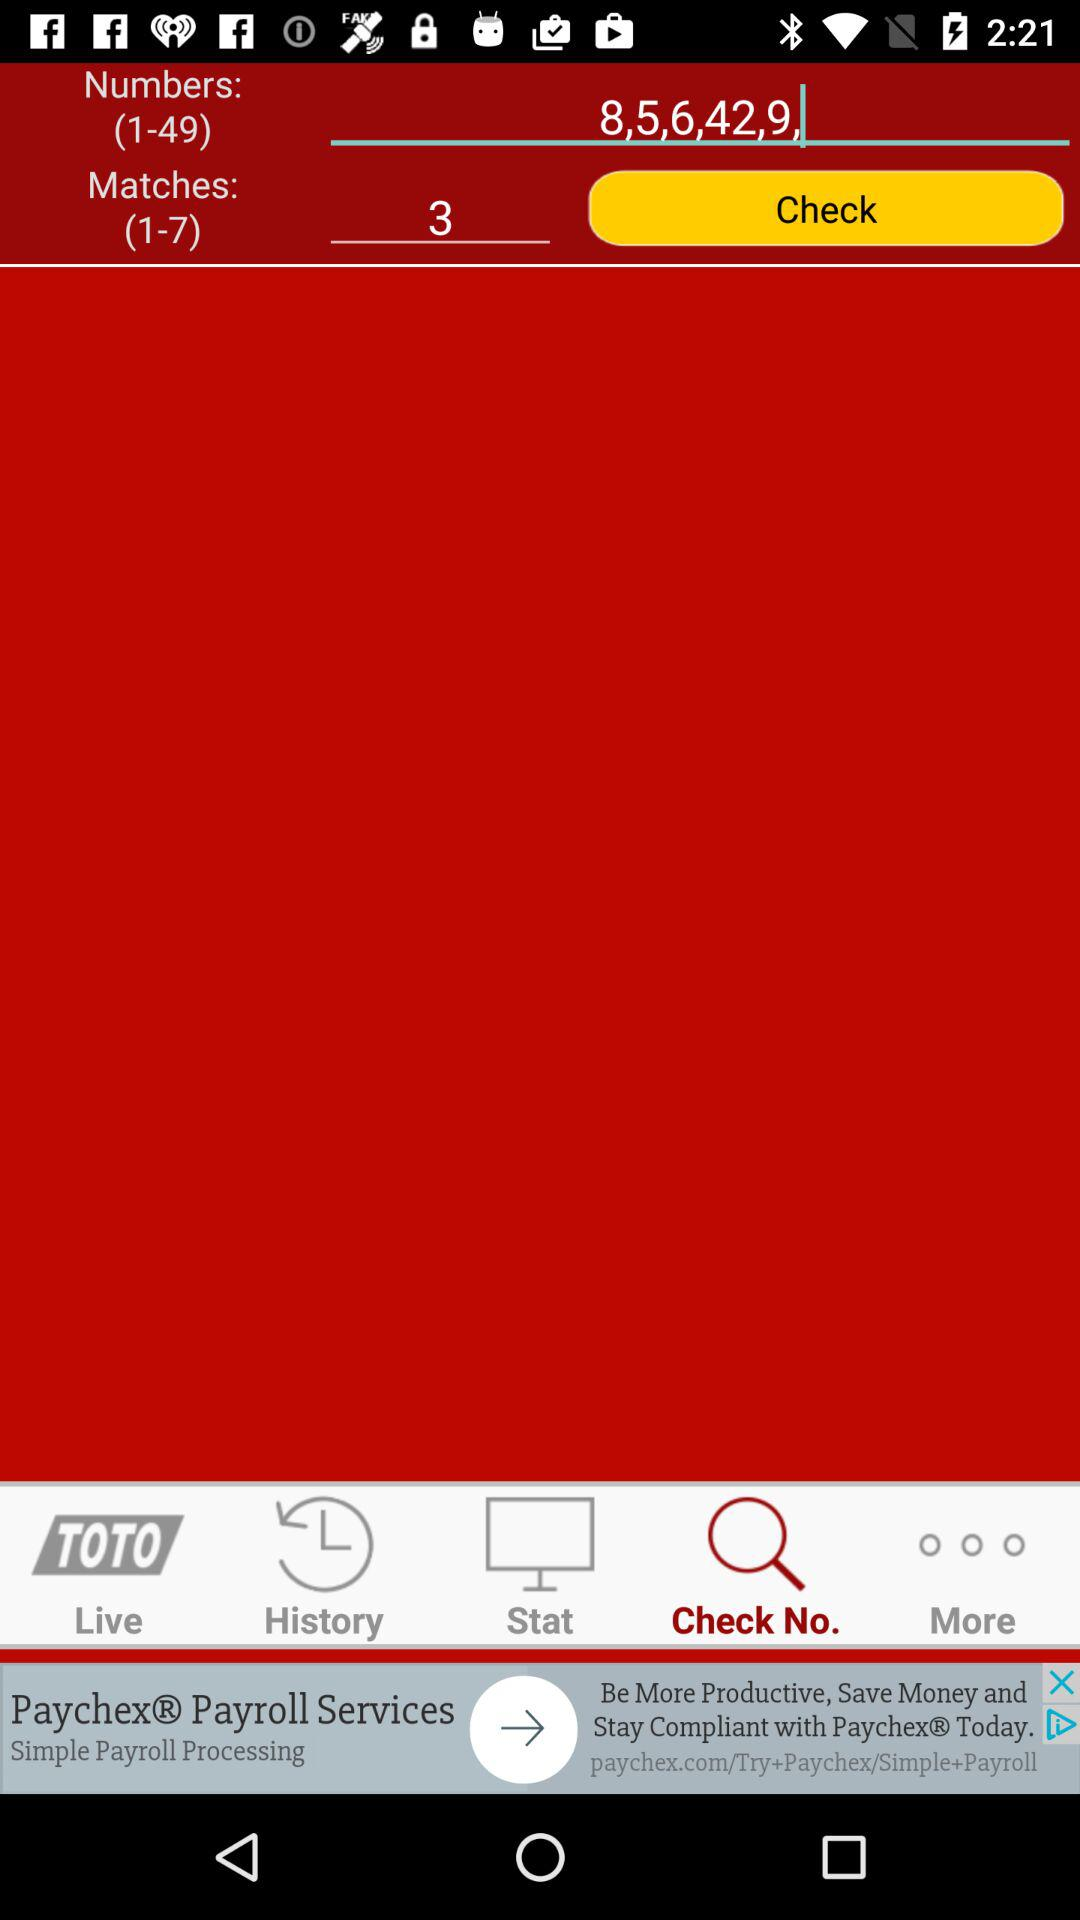Which numbers are entered from the given numbers? The entered numbers are 8, 5, 6, 42 and 9. 